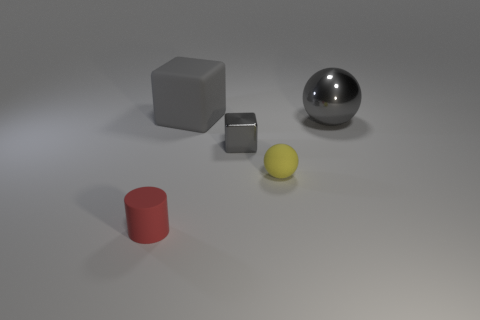Is there anything else that is the same size as the gray rubber thing?
Your answer should be very brief. Yes. Does the block behind the tiny gray metallic block have the same size as the block on the right side of the gray matte cube?
Give a very brief answer. No. How big is the shiny thing to the right of the small ball?
Make the answer very short. Large. What is the material of the small object that is the same color as the big metallic ball?
Your response must be concise. Metal. The block that is the same size as the yellow sphere is what color?
Make the answer very short. Gray. Do the yellow sphere and the gray matte block have the same size?
Give a very brief answer. No. There is a gray object that is both behind the small metallic thing and on the right side of the big matte thing; what is its size?
Provide a short and direct response. Large. What number of rubber things are either cubes or large gray balls?
Provide a succinct answer. 1. Are there more gray cubes that are in front of the big block than tiny blue rubber spheres?
Keep it short and to the point. Yes. What material is the cube that is to the right of the rubber cube?
Keep it short and to the point. Metal. 